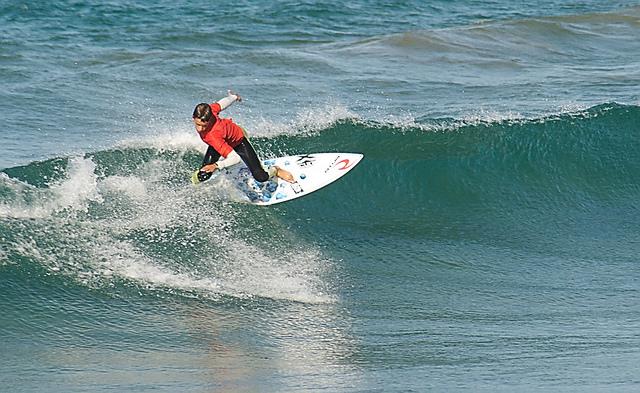What type of water is the man using?
Write a very short answer. Ocean. What is this surfer doing with his feet?
Write a very short answer. Balancing. What wave is the surfer riding on?
Concise answer only. Big one. 